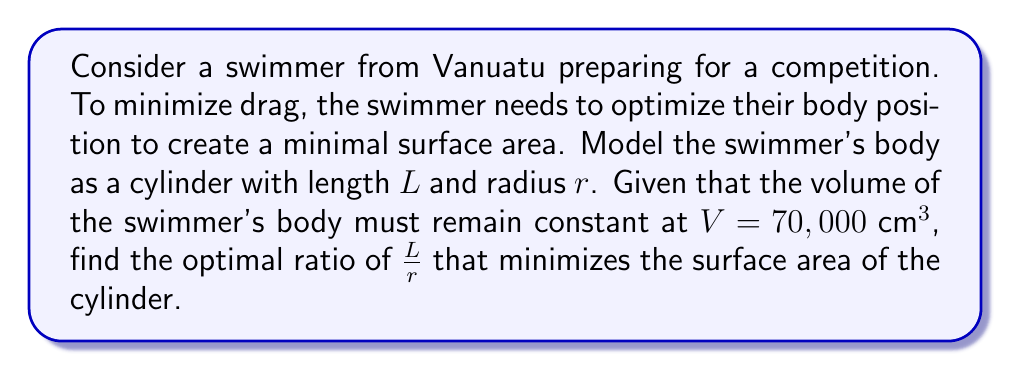Provide a solution to this math problem. Let's approach this step-by-step:

1) The volume of a cylinder is given by:
   $$V = \pi r^2 L$$

2) The surface area of a cylinder (including the circular ends) is:
   $$S = 2\pi r^2 + 2\pi r L$$

3) We're given that $V = 70,000 \text{ cm}^3$. Let's substitute this into the volume equation:
   $$70,000 = \pi r^2 L$$

4) Solve for $L$:
   $$L = \frac{70,000}{\pi r^2}$$

5) Now, substitute this expression for $L$ into the surface area equation:
   $$S = 2\pi r^2 + 2\pi r (\frac{70,000}{\pi r^2})$$

6) Simplify:
   $$S = 2\pi r^2 + \frac{140,000}{r}$$

7) To find the minimum surface area, we need to differentiate $S$ with respect to $r$ and set it to zero:
   $$\frac{dS}{dr} = 4\pi r - \frac{140,000}{r^2} = 0$$

8) Solve this equation:
   $$4\pi r^3 = 140,000$$
   $$r^3 = \frac{35,000}{\pi}$$
   $$r = \sqrt[3]{\frac{35,000}{\pi}}$$

9) Now that we have $r$, we can find $L$ using the equation from step 4:
   $$L = \frac{70,000}{\pi (\sqrt[3]{\frac{35,000}{\pi}})^2}$$

10) Simplify:
    $$L = 2\sqrt[3]{\frac{35,000}{\pi}}$$

11) The optimal ratio $\frac{L}{r}$ is therefore:
    $$\frac{L}{r} = \frac{2\sqrt[3]{\frac{35,000}{\pi}}}{\sqrt[3]{\frac{35,000}{\pi}}} = 2$$

Therefore, the optimal ratio of length to radius is 2:1.
Answer: $\frac{L}{r} = 2$ 